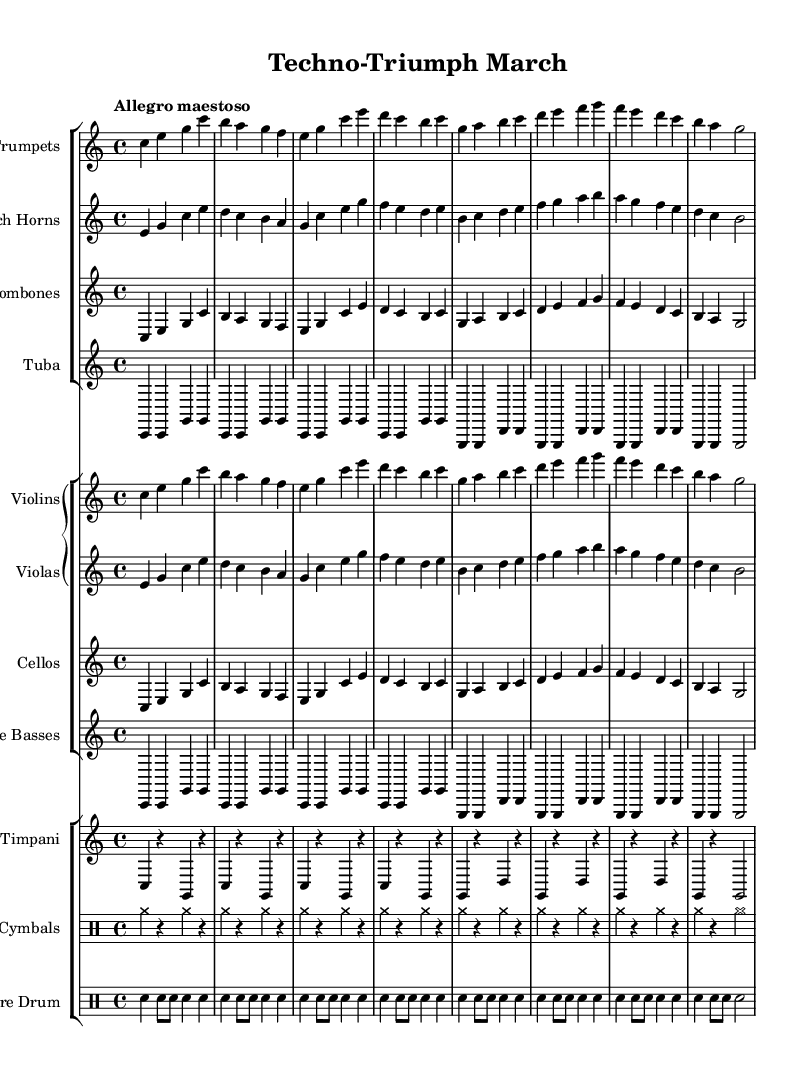What is the time signature of this music? The time signature is found at the beginning of the score and is indicated as 4/4. This means there are four beats in each measure, and the quarter note gets one beat.
Answer: 4/4 What is the key signature of this music? The key signature is located at the beginning of the staff after the clef. Since there are no sharps or flats, it indicates the piece is in C major.
Answer: C major What is the tempo marking for this music? The tempo marking is written above the staff and describes the speed of the music. It states "Allegro maestoso," suggesting a fast and majestic pace.
Answer: Allegro maestoso How many different instruments are used in this piece? By counting the number of unique instrument staves in the score, we find that there are nine distinct instruments (Trumpets, French Horns, Trombones, Tuba, Violins, Violas, Cellos, Double Basses, Timpani, Cymbals, Snare Drum).
Answer: Eleven What is the orchestration pattern for the strings? By analyzing the grouping of strings in the score, it shows that Violins and Violas are part of a Grand Staff, while Cellos and Double Basses are in separate staves beneath them. This shows a typical orchestration layout for strings that allows for rich harmonic support and layering.
Answer: Violins, Violas, Cellos, Double Basses What rhythmic value is assigned to the first note of the Trumpets? The first note is a quarter note, indicated by the note head and stem on the staff, which defines its rhythmic duration.
Answer: Quarter 